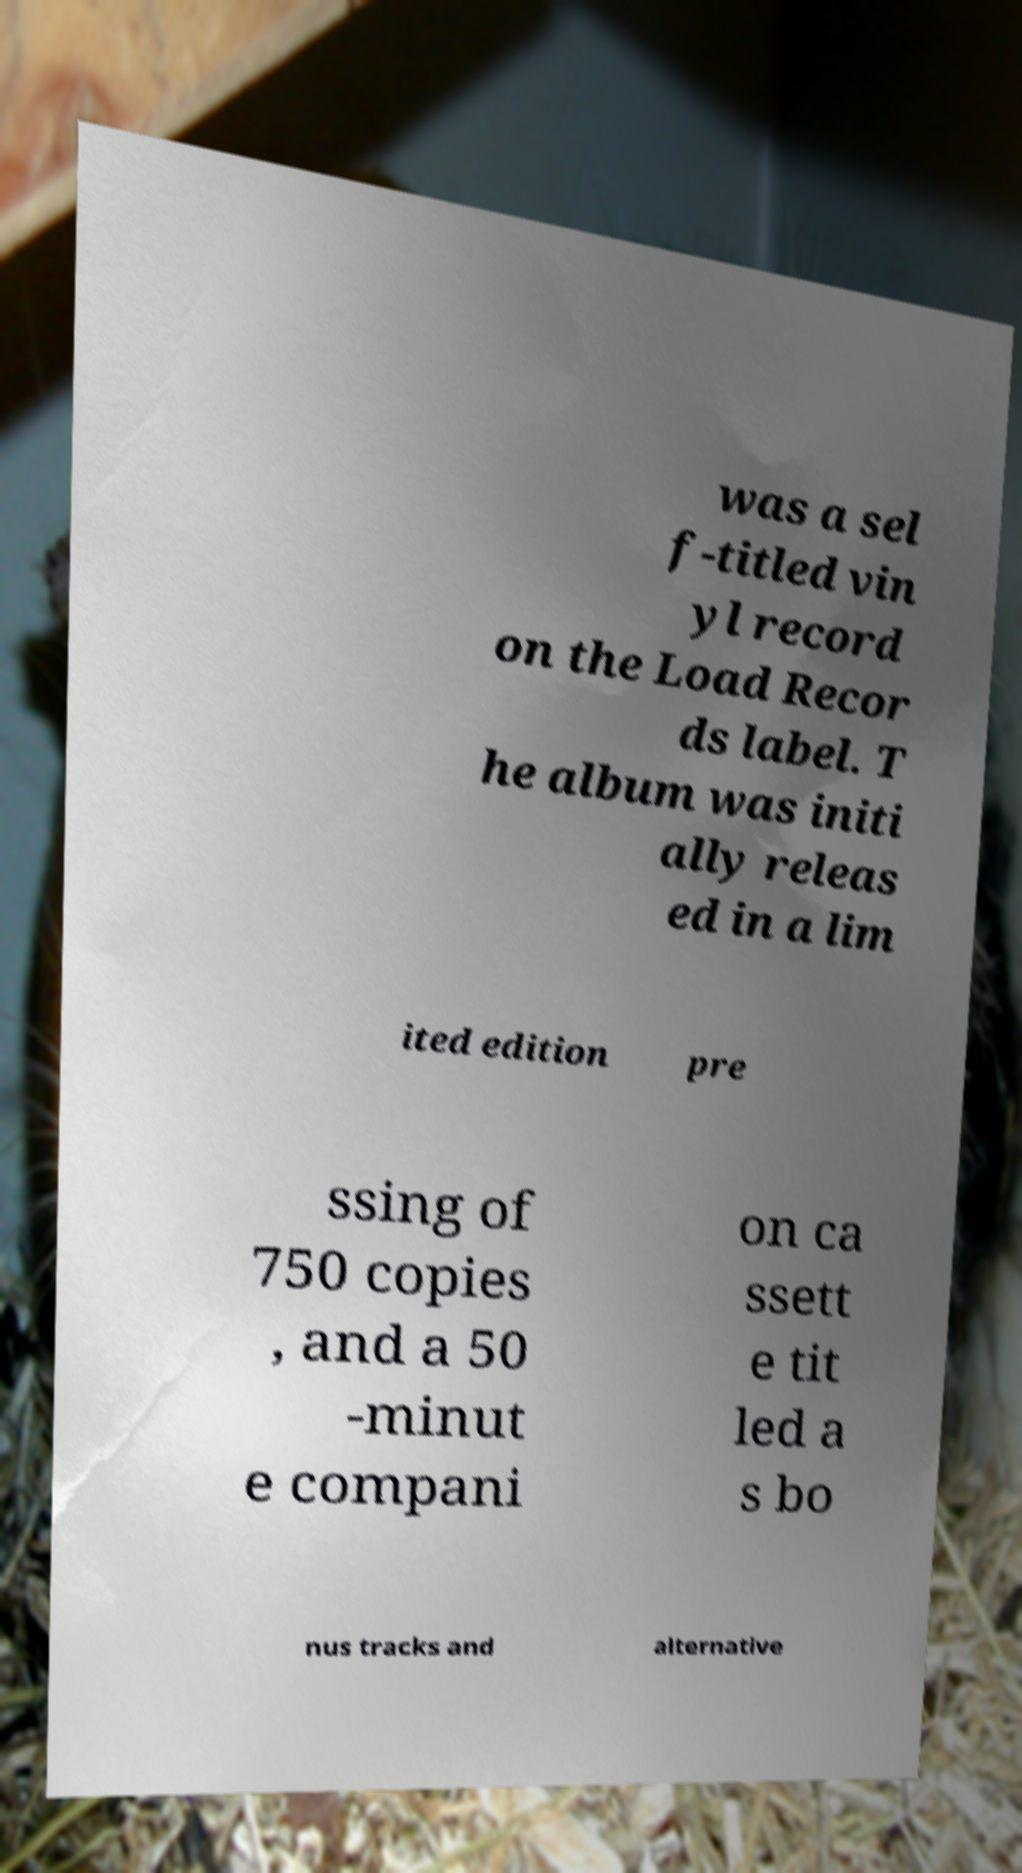Please read and relay the text visible in this image. What does it say? was a sel f-titled vin yl record on the Load Recor ds label. T he album was initi ally releas ed in a lim ited edition pre ssing of 750 copies , and a 50 -minut e compani on ca ssett e tit led a s bo nus tracks and alternative 